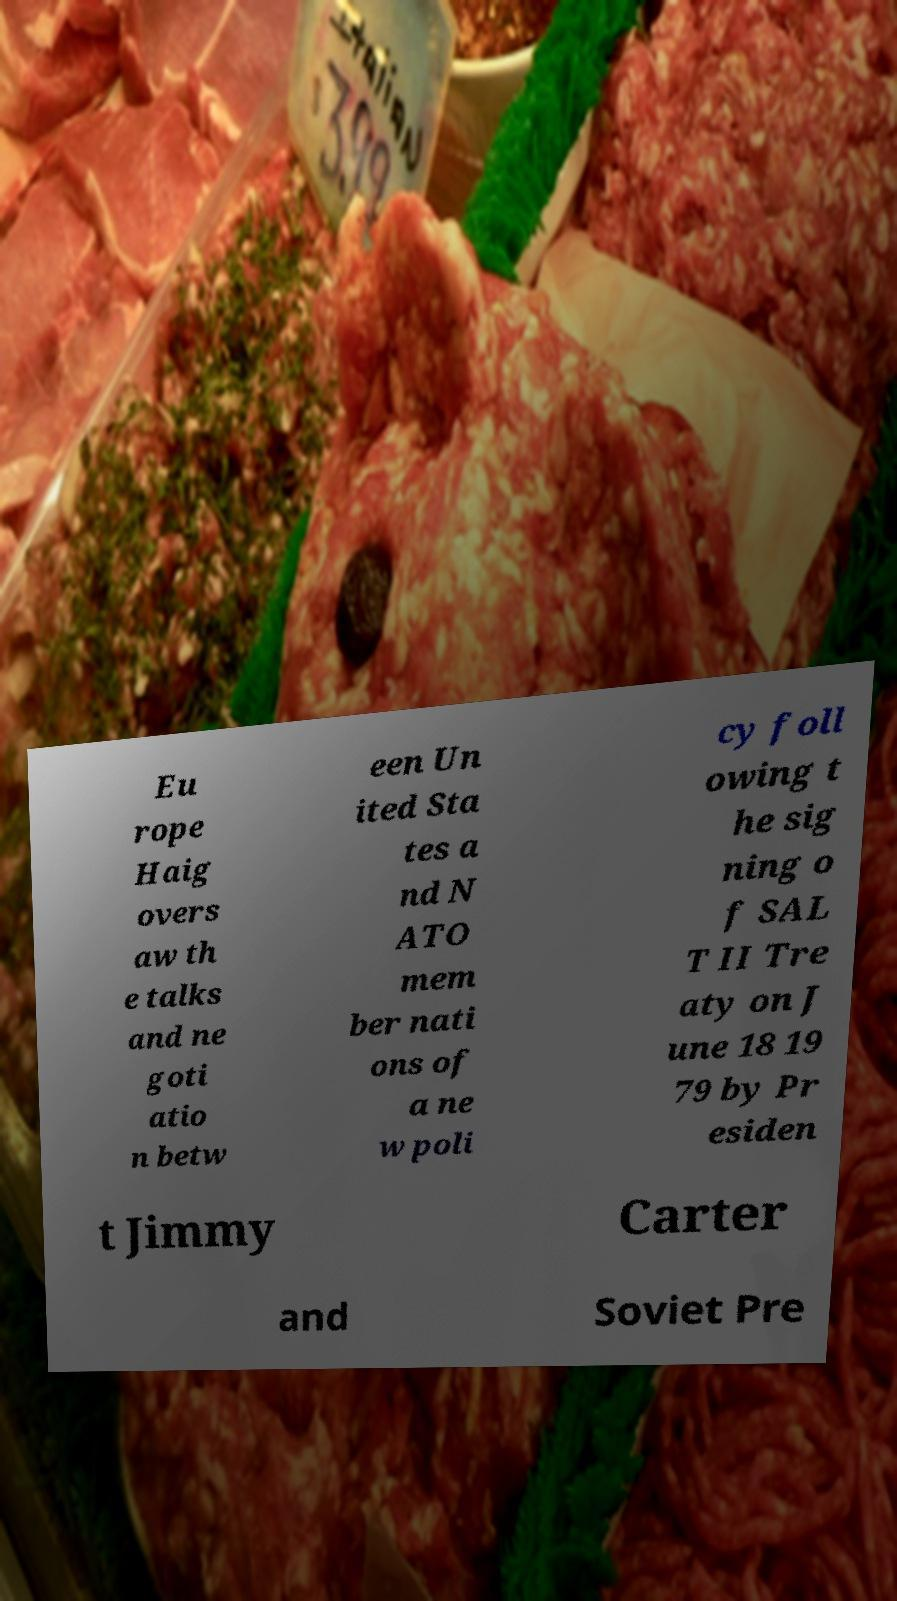Can you accurately transcribe the text from the provided image for me? Eu rope Haig overs aw th e talks and ne goti atio n betw een Un ited Sta tes a nd N ATO mem ber nati ons of a ne w poli cy foll owing t he sig ning o f SAL T II Tre aty on J une 18 19 79 by Pr esiden t Jimmy Carter and Soviet Pre 